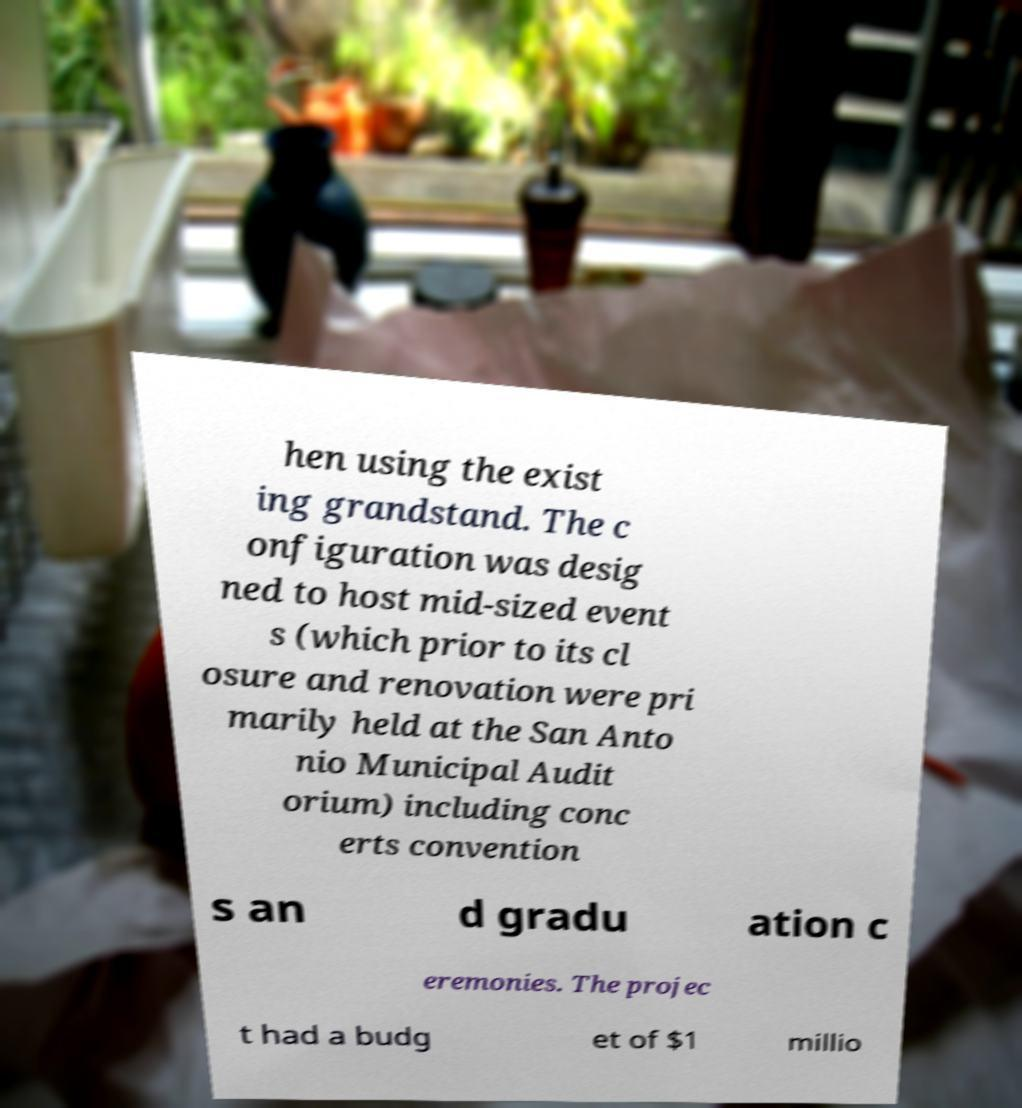There's text embedded in this image that I need extracted. Can you transcribe it verbatim? hen using the exist ing grandstand. The c onfiguration was desig ned to host mid-sized event s (which prior to its cl osure and renovation were pri marily held at the San Anto nio Municipal Audit orium) including conc erts convention s an d gradu ation c eremonies. The projec t had a budg et of $1 millio 